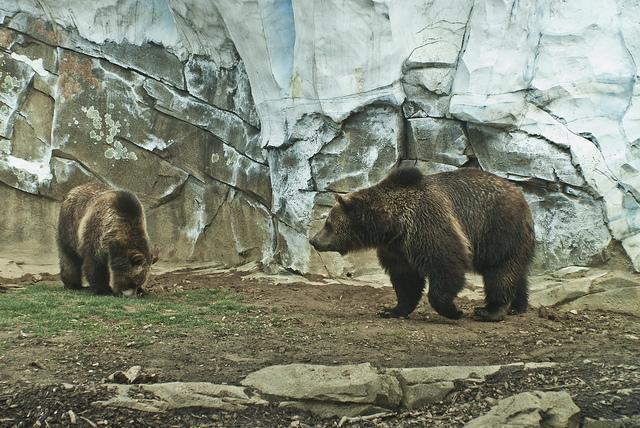How many animals are there?
Give a very brief answer. 2. How many bears are there?
Give a very brief answer. 2. 